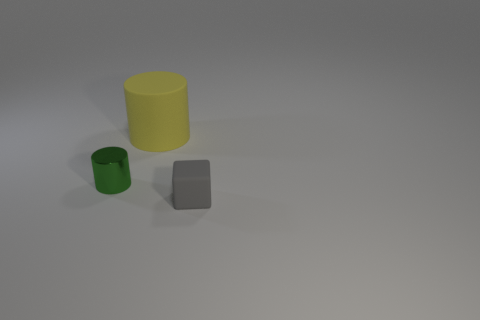Is the shape of the yellow matte thing the same as the metallic object?
Offer a very short reply. Yes. How many things are cylinders that are right of the tiny cylinder or metal things?
Offer a terse response. 2. Is there a large yellow thing that has the same shape as the green object?
Offer a terse response. Yes. Are there the same number of yellow objects that are on the right side of the small cylinder and large yellow matte cylinders?
Give a very brief answer. Yes. What number of shiny cylinders are the same size as the block?
Ensure brevity in your answer.  1. There is a tiny gray matte thing; how many objects are behind it?
Offer a very short reply. 2. What is the material of the tiny thing to the right of the thing behind the metal cylinder?
Provide a short and direct response. Rubber. There is a yellow cylinder that is made of the same material as the gray object; what is its size?
Your response must be concise. Large. What color is the thing to the right of the large cylinder?
Ensure brevity in your answer.  Gray. There is a cylinder that is on the left side of the matte object to the left of the gray thing; is there a object on the right side of it?
Provide a succinct answer. Yes. 